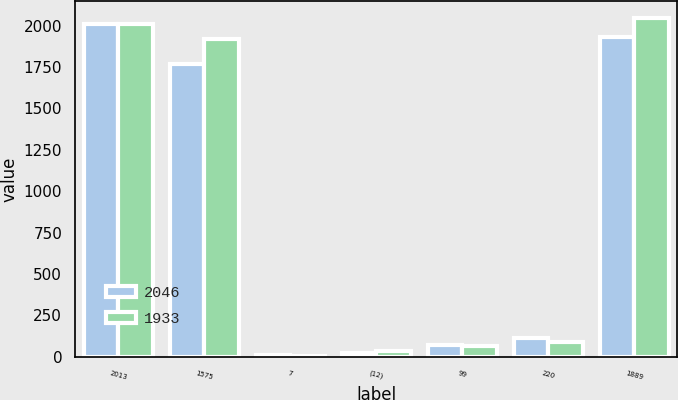Convert chart to OTSL. <chart><loc_0><loc_0><loc_500><loc_500><stacked_bar_chart><ecel><fcel>2013<fcel>1575<fcel>7<fcel>(12)<fcel>99<fcel>220<fcel>1889<nl><fcel>2046<fcel>2012<fcel>1768<fcel>7<fcel>25<fcel>73<fcel>110<fcel>1933<nl><fcel>1933<fcel>2011<fcel>1917<fcel>6<fcel>32<fcel>64<fcel>91<fcel>2046<nl></chart> 